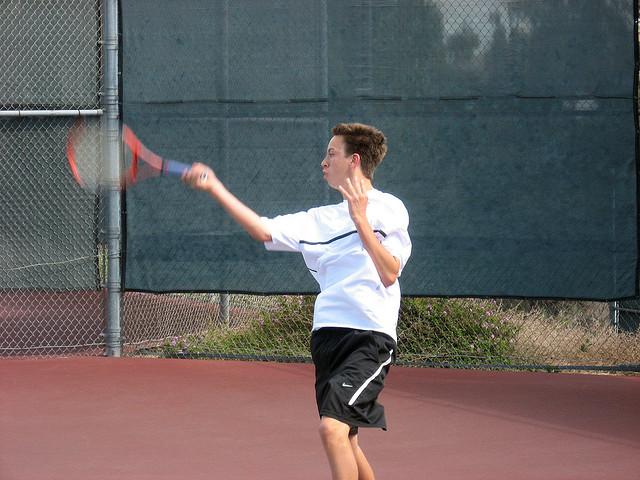What image appears on the tennis player's shirt?
Keep it brief. Stripe. Is this a man or a woman?
Give a very brief answer. Man. What is the man holding?
Answer briefly. Tennis racket. What color shorts is this person wearing?
Short answer required. Black. Is there a shadow?
Quick response, please. Yes. Is this person a man or a woman?
Be succinct. Man. 